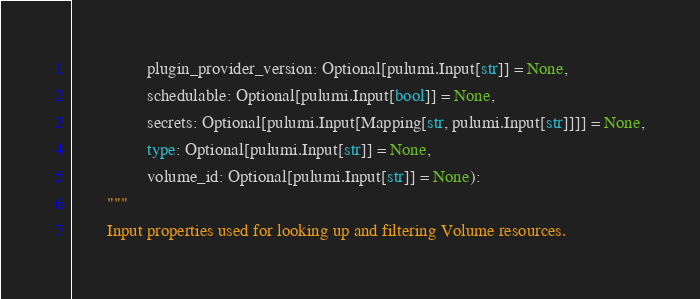Convert code to text. <code><loc_0><loc_0><loc_500><loc_500><_Python_>                 plugin_provider_version: Optional[pulumi.Input[str]] = None,
                 schedulable: Optional[pulumi.Input[bool]] = None,
                 secrets: Optional[pulumi.Input[Mapping[str, pulumi.Input[str]]]] = None,
                 type: Optional[pulumi.Input[str]] = None,
                 volume_id: Optional[pulumi.Input[str]] = None):
        """
        Input properties used for looking up and filtering Volume resources.</code> 